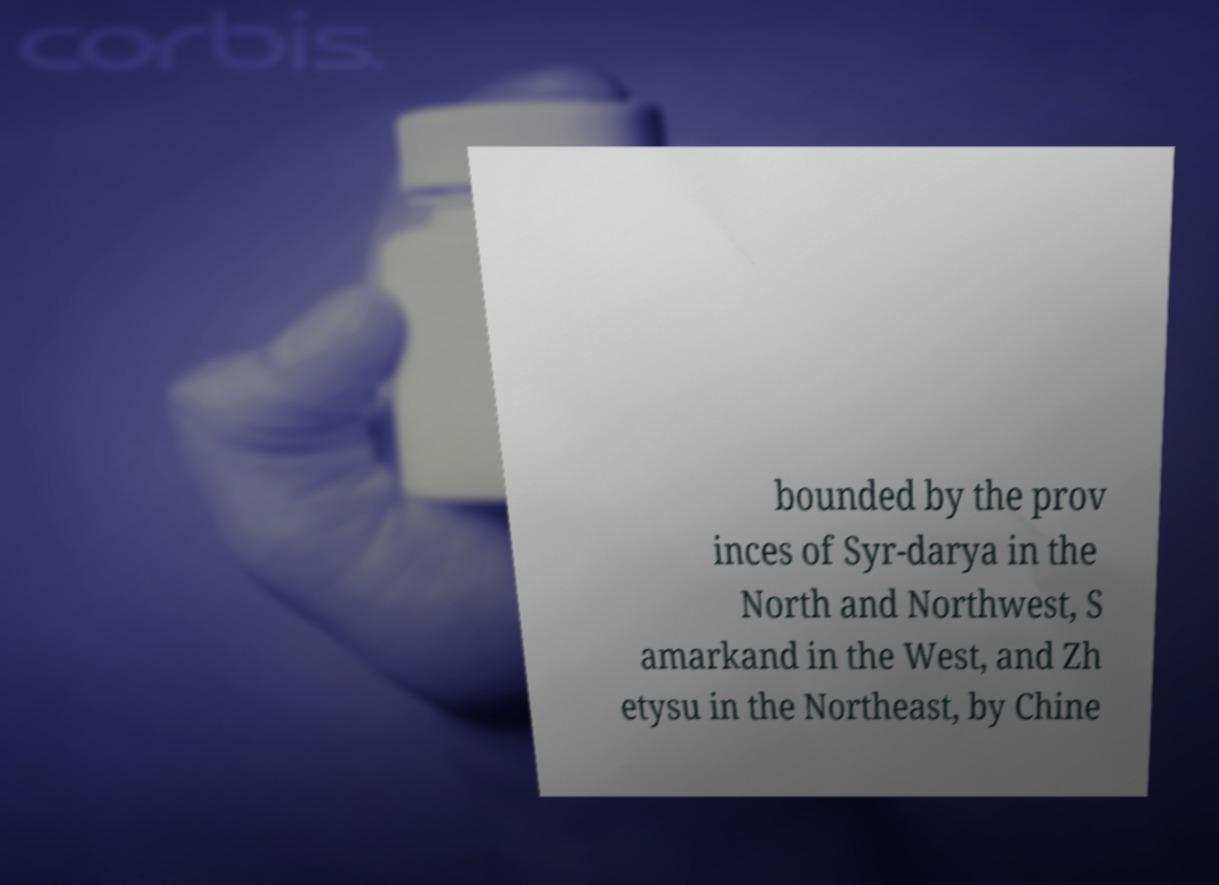Can you accurately transcribe the text from the provided image for me? bounded by the prov inces of Syr-darya in the North and Northwest, S amarkand in the West, and Zh etysu in the Northeast, by Chine 